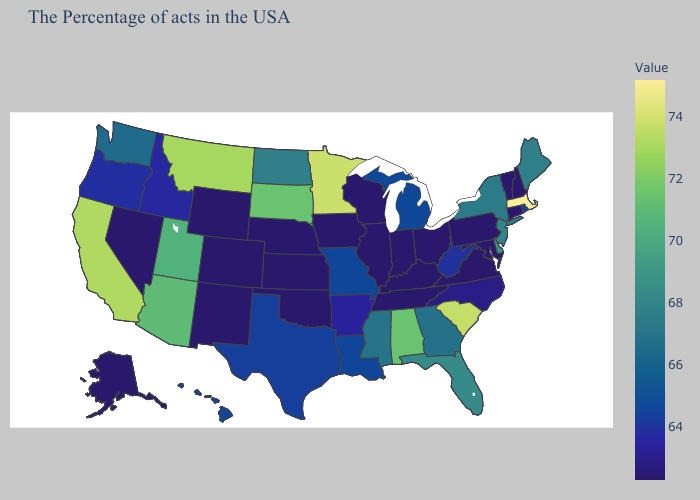Among the states that border Nebraska , does Missouri have the lowest value?
Keep it brief. No. Does Florida have a higher value than Nevada?
Be succinct. Yes. Which states hav the highest value in the West?
Short answer required. California. Does Ohio have the highest value in the MidWest?
Quick response, please. No. Does Illinois have the lowest value in the MidWest?
Answer briefly. Yes. Is the legend a continuous bar?
Write a very short answer. Yes. 